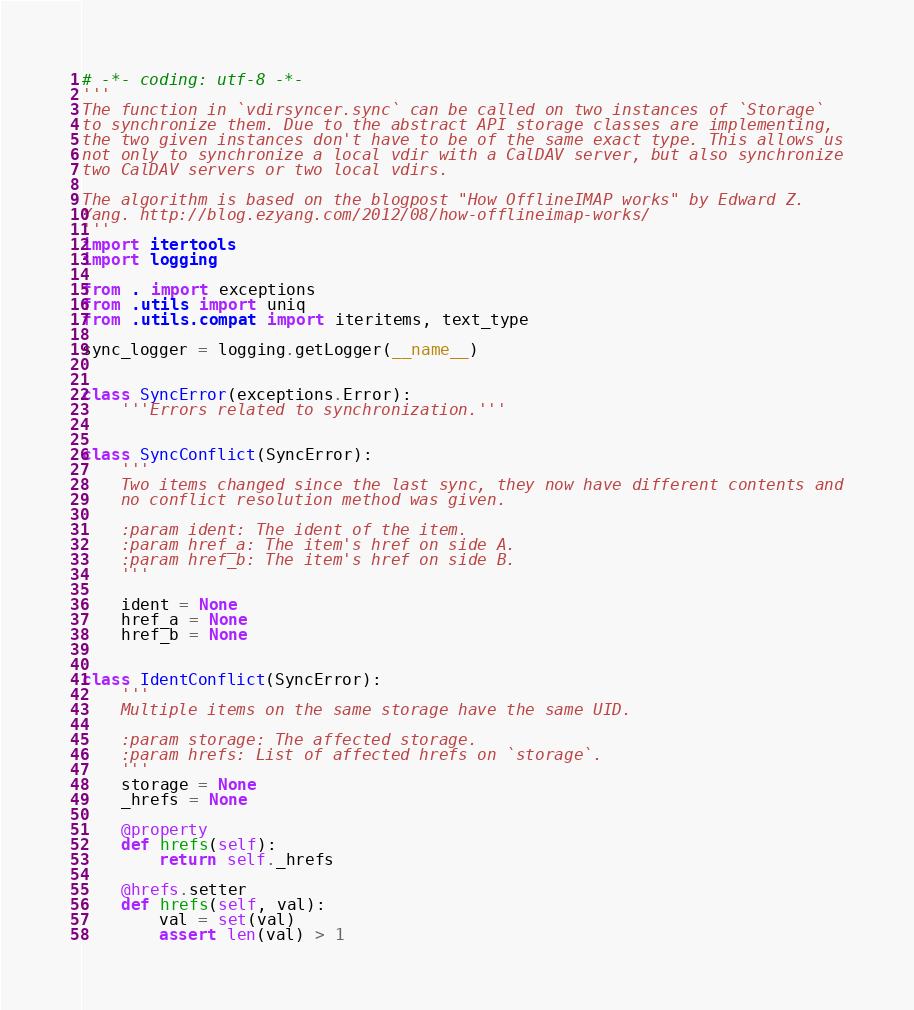<code> <loc_0><loc_0><loc_500><loc_500><_Python_># -*- coding: utf-8 -*-
'''
The function in `vdirsyncer.sync` can be called on two instances of `Storage`
to synchronize them. Due to the abstract API storage classes are implementing,
the two given instances don't have to be of the same exact type. This allows us
not only to synchronize a local vdir with a CalDAV server, but also synchronize
two CalDAV servers or two local vdirs.

The algorithm is based on the blogpost "How OfflineIMAP works" by Edward Z.
Yang. http://blog.ezyang.com/2012/08/how-offlineimap-works/
'''
import itertools
import logging

from . import exceptions
from .utils import uniq
from .utils.compat import iteritems, text_type

sync_logger = logging.getLogger(__name__)


class SyncError(exceptions.Error):
    '''Errors related to synchronization.'''


class SyncConflict(SyncError):
    '''
    Two items changed since the last sync, they now have different contents and
    no conflict resolution method was given.

    :param ident: The ident of the item.
    :param href_a: The item's href on side A.
    :param href_b: The item's href on side B.
    '''

    ident = None
    href_a = None
    href_b = None


class IdentConflict(SyncError):
    '''
    Multiple items on the same storage have the same UID.

    :param storage: The affected storage.
    :param hrefs: List of affected hrefs on `storage`.
    '''
    storage = None
    _hrefs = None

    @property
    def hrefs(self):
        return self._hrefs

    @hrefs.setter
    def hrefs(self, val):
        val = set(val)
        assert len(val) > 1</code> 